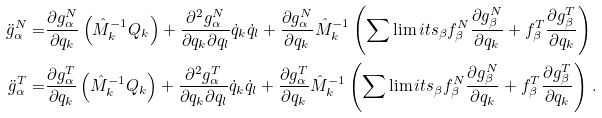<formula> <loc_0><loc_0><loc_500><loc_500>\ddot { g } _ { \alpha } ^ { N } = & \frac { \partial g ^ { N } _ { \alpha } } { \partial q _ { k } } \left ( \hat { M } _ { k } ^ { - 1 } Q _ { k } \right ) + \frac { \partial ^ { 2 } g ^ { N } _ { \alpha } } { \partial q _ { k } \partial q _ { l } } \dot { q } _ { k } \dot { q } _ { l } + \frac { \partial g ^ { N } _ { \alpha } } { \partial q _ { k } } \hat { M } _ { k } ^ { - 1 } \left ( \sum \lim i t s _ { \beta } f ^ { N } _ { \beta } \frac { \partial g ^ { N } _ { \beta } } { \partial q _ { k } } + f ^ { T } _ { \beta } \frac { \partial g ^ { T } _ { \beta } } { \partial q _ { k } } \right ) \\ \ddot { g } _ { \alpha } ^ { T } = & \frac { \partial g ^ { T } _ { \alpha } } { \partial q _ { k } } \left ( \hat { M } _ { k } ^ { - 1 } Q _ { k } \right ) + \frac { \partial ^ { 2 } g ^ { T } _ { \alpha } } { \partial q _ { k } \partial q _ { l } } \dot { q } _ { k } \dot { q } _ { l } + \frac { \partial g ^ { T } _ { \alpha } } { \partial q _ { k } } \hat { M } _ { k } ^ { - 1 } \left ( \sum \lim i t s _ { \beta } f ^ { N } _ { \beta } \frac { \partial g ^ { N } _ { \beta } } { \partial q _ { k } } + f ^ { T } _ { \beta } \frac { \partial g ^ { T } _ { \beta } } { \partial q _ { k } } \right ) \, .</formula> 